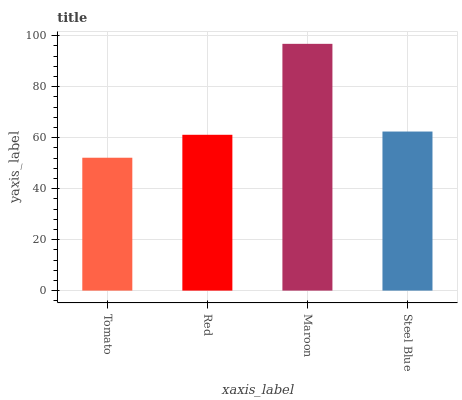Is Tomato the minimum?
Answer yes or no. Yes. Is Maroon the maximum?
Answer yes or no. Yes. Is Red the minimum?
Answer yes or no. No. Is Red the maximum?
Answer yes or no. No. Is Red greater than Tomato?
Answer yes or no. Yes. Is Tomato less than Red?
Answer yes or no. Yes. Is Tomato greater than Red?
Answer yes or no. No. Is Red less than Tomato?
Answer yes or no. No. Is Steel Blue the high median?
Answer yes or no. Yes. Is Red the low median?
Answer yes or no. Yes. Is Maroon the high median?
Answer yes or no. No. Is Tomato the low median?
Answer yes or no. No. 